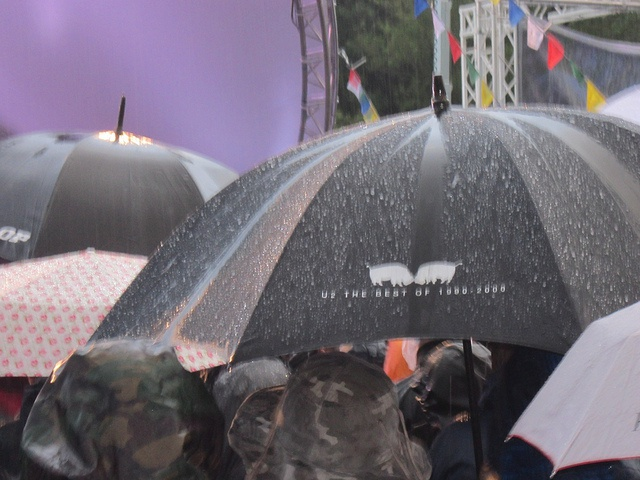Describe the objects in this image and their specific colors. I can see umbrella in violet, gray, darkgray, and black tones, umbrella in violet, gray, darkgray, and lightgray tones, people in violet, black, gray, and darkgray tones, people in violet, gray, and black tones, and umbrella in violet, lightgray, pink, and darkgray tones in this image. 